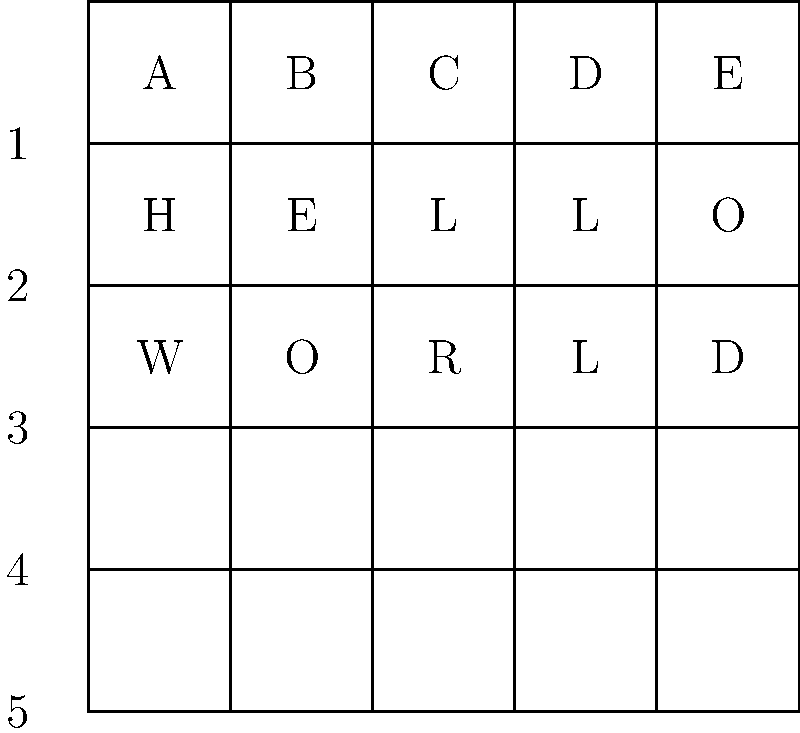You've intercepted a message using a simple substitution cipher based on the grid above. If the message reads "B3 D1 A4 C2", what does it decode to? To decode the message, we need to follow these steps:

1. Understand the cipher: Each letter in the coded message represents a cell in the grid. The letter (A-E) represents the column, and the number (1-5) represents the row.

2. Decode each part of the message:
   - B3: Column B, Row 3 → "O"
   - D1: Column D, Row 1 → "L"
   - A4: Column A, Row 4 → "E"
   - C2: Column C, Row 2 → "R"

3. Combine the decoded letters:
   O + L + E + R = "OLER"

Therefore, the decoded message is "OLER".
Answer: OLER 